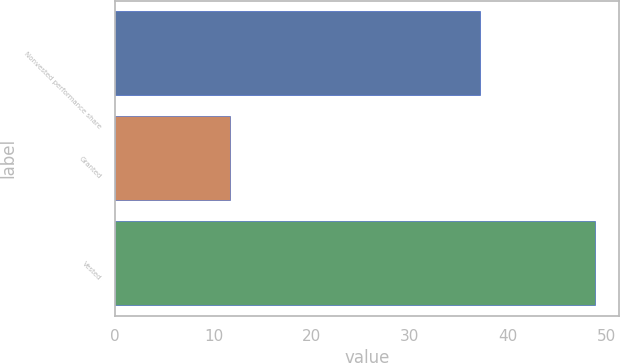Convert chart to OTSL. <chart><loc_0><loc_0><loc_500><loc_500><bar_chart><fcel>Nonvested performance share<fcel>Granted<fcel>Vested<nl><fcel>37.14<fcel>11.64<fcel>48.89<nl></chart> 